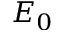<formula> <loc_0><loc_0><loc_500><loc_500>E _ { 0 }</formula> 